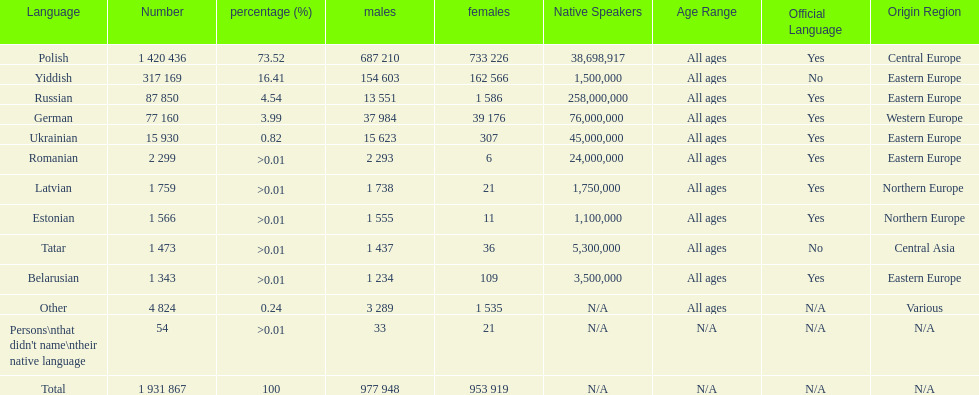Which language had the smallest number of females speaking it. Romanian. 